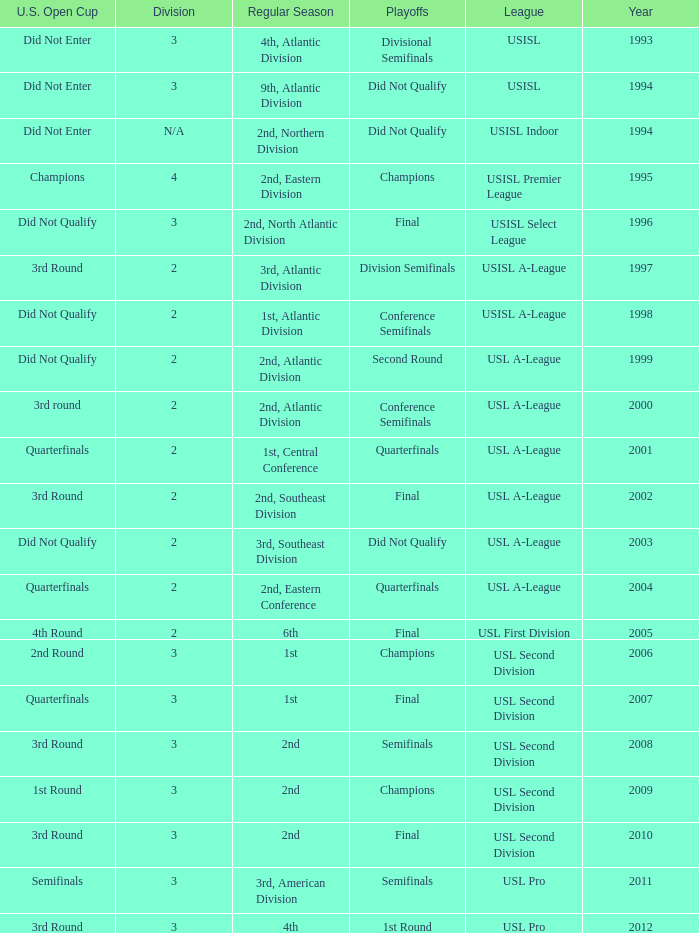What are all the playoffs for regular season is 1st, atlantic division Conference Semifinals. Would you be able to parse every entry in this table? {'header': ['U.S. Open Cup', 'Division', 'Regular Season', 'Playoffs', 'League', 'Year'], 'rows': [['Did Not Enter', '3', '4th, Atlantic Division', 'Divisional Semifinals', 'USISL', '1993'], ['Did Not Enter', '3', '9th, Atlantic Division', 'Did Not Qualify', 'USISL', '1994'], ['Did Not Enter', 'N/A', '2nd, Northern Division', 'Did Not Qualify', 'USISL Indoor', '1994'], ['Champions', '4', '2nd, Eastern Division', 'Champions', 'USISL Premier League', '1995'], ['Did Not Qualify', '3', '2nd, North Atlantic Division', 'Final', 'USISL Select League', '1996'], ['3rd Round', '2', '3rd, Atlantic Division', 'Division Semifinals', 'USISL A-League', '1997'], ['Did Not Qualify', '2', '1st, Atlantic Division', 'Conference Semifinals', 'USISL A-League', '1998'], ['Did Not Qualify', '2', '2nd, Atlantic Division', 'Second Round', 'USL A-League', '1999'], ['3rd round', '2', '2nd, Atlantic Division', 'Conference Semifinals', 'USL A-League', '2000'], ['Quarterfinals', '2', '1st, Central Conference', 'Quarterfinals', 'USL A-League', '2001'], ['3rd Round', '2', '2nd, Southeast Division', 'Final', 'USL A-League', '2002'], ['Did Not Qualify', '2', '3rd, Southeast Division', 'Did Not Qualify', 'USL A-League', '2003'], ['Quarterfinals', '2', '2nd, Eastern Conference', 'Quarterfinals', 'USL A-League', '2004'], ['4th Round', '2', '6th', 'Final', 'USL First Division', '2005'], ['2nd Round', '3', '1st', 'Champions', 'USL Second Division', '2006'], ['Quarterfinals', '3', '1st', 'Final', 'USL Second Division', '2007'], ['3rd Round', '3', '2nd', 'Semifinals', 'USL Second Division', '2008'], ['1st Round', '3', '2nd', 'Champions', 'USL Second Division', '2009'], ['3rd Round', '3', '2nd', 'Final', 'USL Second Division', '2010'], ['Semifinals', '3', '3rd, American Division', 'Semifinals', 'USL Pro', '2011'], ['3rd Round', '3', '4th', '1st Round', 'USL Pro', '2012']]} 